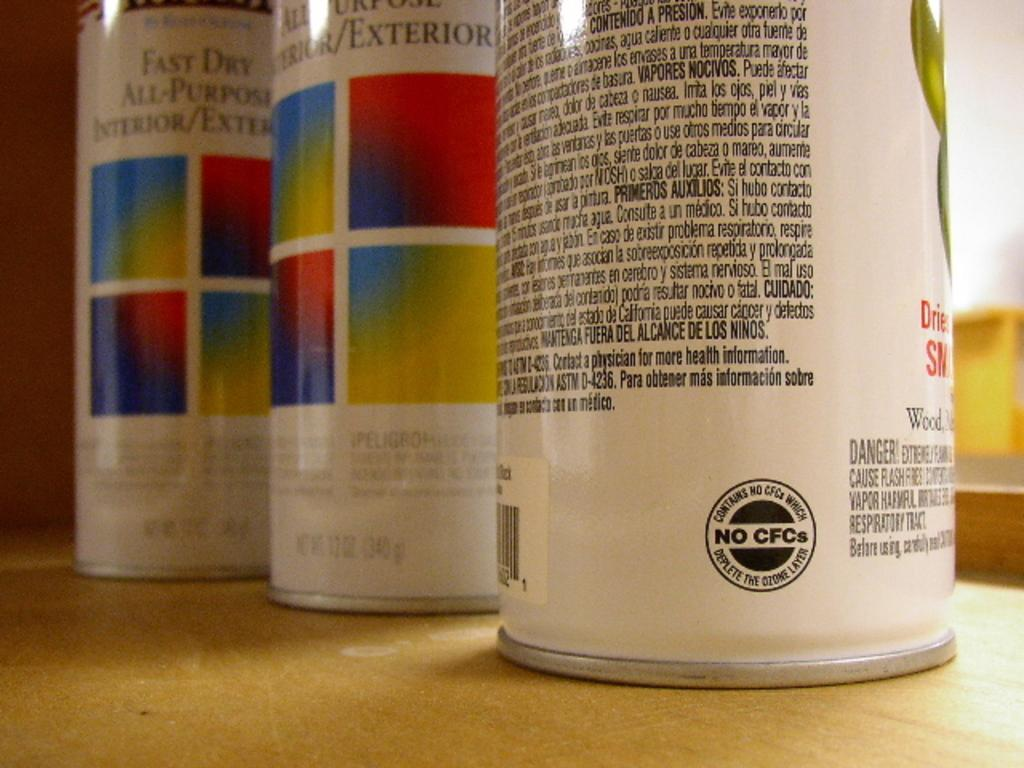How many cans are visible in the image? There are three cans in the image. What can be found on the cans? There is writing on the cans. What type of vest is being worn by the person in the image? There is no person present in the image, and therefore no vest can be observed. 